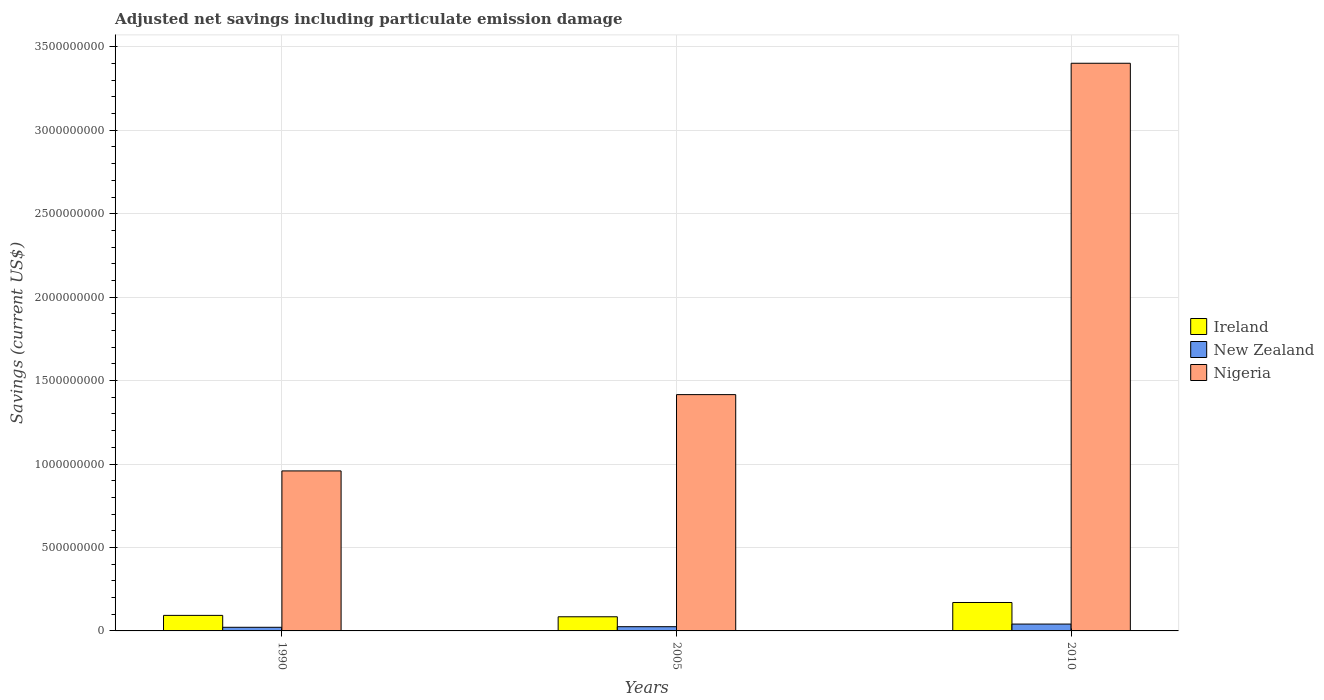How many different coloured bars are there?
Offer a terse response. 3. Are the number of bars per tick equal to the number of legend labels?
Provide a short and direct response. Yes. How many bars are there on the 2nd tick from the left?
Your response must be concise. 3. How many bars are there on the 3rd tick from the right?
Your response must be concise. 3. What is the label of the 1st group of bars from the left?
Make the answer very short. 1990. In how many cases, is the number of bars for a given year not equal to the number of legend labels?
Make the answer very short. 0. What is the net savings in Ireland in 2005?
Provide a succinct answer. 8.48e+07. Across all years, what is the maximum net savings in New Zealand?
Ensure brevity in your answer.  4.10e+07. Across all years, what is the minimum net savings in Nigeria?
Offer a very short reply. 9.59e+08. In which year was the net savings in Ireland minimum?
Keep it short and to the point. 2005. What is the total net savings in New Zealand in the graph?
Provide a succinct answer. 8.81e+07. What is the difference between the net savings in New Zealand in 2005 and that in 2010?
Provide a succinct answer. -1.57e+07. What is the difference between the net savings in Ireland in 2005 and the net savings in New Zealand in 1990?
Provide a succinct answer. 6.30e+07. What is the average net savings in New Zealand per year?
Your response must be concise. 2.94e+07. In the year 1990, what is the difference between the net savings in New Zealand and net savings in Nigeria?
Your response must be concise. -9.37e+08. What is the ratio of the net savings in Ireland in 1990 to that in 2010?
Your answer should be very brief. 0.55. Is the net savings in Ireland in 1990 less than that in 2005?
Offer a very short reply. No. Is the difference between the net savings in New Zealand in 1990 and 2010 greater than the difference between the net savings in Nigeria in 1990 and 2010?
Give a very brief answer. Yes. What is the difference between the highest and the second highest net savings in Ireland?
Make the answer very short. 7.72e+07. What is the difference between the highest and the lowest net savings in Nigeria?
Provide a succinct answer. 2.44e+09. Is the sum of the net savings in New Zealand in 2005 and 2010 greater than the maximum net savings in Nigeria across all years?
Offer a very short reply. No. What does the 1st bar from the left in 2005 represents?
Offer a terse response. Ireland. What does the 3rd bar from the right in 2005 represents?
Give a very brief answer. Ireland. Is it the case that in every year, the sum of the net savings in New Zealand and net savings in Ireland is greater than the net savings in Nigeria?
Your response must be concise. No. How many bars are there?
Your answer should be very brief. 9. Are all the bars in the graph horizontal?
Your answer should be compact. No. How many years are there in the graph?
Offer a very short reply. 3. Does the graph contain any zero values?
Your answer should be very brief. No. Does the graph contain grids?
Your answer should be compact. Yes. How many legend labels are there?
Provide a short and direct response. 3. What is the title of the graph?
Ensure brevity in your answer.  Adjusted net savings including particulate emission damage. What is the label or title of the Y-axis?
Your answer should be very brief. Savings (current US$). What is the Savings (current US$) of Ireland in 1990?
Give a very brief answer. 9.31e+07. What is the Savings (current US$) of New Zealand in 1990?
Your answer should be compact. 2.18e+07. What is the Savings (current US$) of Nigeria in 1990?
Provide a short and direct response. 9.59e+08. What is the Savings (current US$) in Ireland in 2005?
Offer a very short reply. 8.48e+07. What is the Savings (current US$) in New Zealand in 2005?
Keep it short and to the point. 2.54e+07. What is the Savings (current US$) of Nigeria in 2005?
Ensure brevity in your answer.  1.42e+09. What is the Savings (current US$) in Ireland in 2010?
Your response must be concise. 1.70e+08. What is the Savings (current US$) in New Zealand in 2010?
Your response must be concise. 4.10e+07. What is the Savings (current US$) in Nigeria in 2010?
Your response must be concise. 3.40e+09. Across all years, what is the maximum Savings (current US$) of Ireland?
Offer a very short reply. 1.70e+08. Across all years, what is the maximum Savings (current US$) in New Zealand?
Make the answer very short. 4.10e+07. Across all years, what is the maximum Savings (current US$) of Nigeria?
Your answer should be very brief. 3.40e+09. Across all years, what is the minimum Savings (current US$) of Ireland?
Ensure brevity in your answer.  8.48e+07. Across all years, what is the minimum Savings (current US$) in New Zealand?
Keep it short and to the point. 2.18e+07. Across all years, what is the minimum Savings (current US$) of Nigeria?
Provide a succinct answer. 9.59e+08. What is the total Savings (current US$) of Ireland in the graph?
Make the answer very short. 3.48e+08. What is the total Savings (current US$) of New Zealand in the graph?
Your response must be concise. 8.81e+07. What is the total Savings (current US$) of Nigeria in the graph?
Ensure brevity in your answer.  5.78e+09. What is the difference between the Savings (current US$) in Ireland in 1990 and that in 2005?
Keep it short and to the point. 8.30e+06. What is the difference between the Savings (current US$) in New Zealand in 1990 and that in 2005?
Offer a very short reply. -3.60e+06. What is the difference between the Savings (current US$) in Nigeria in 1990 and that in 2005?
Your answer should be compact. -4.57e+08. What is the difference between the Savings (current US$) in Ireland in 1990 and that in 2010?
Provide a succinct answer. -7.72e+07. What is the difference between the Savings (current US$) of New Zealand in 1990 and that in 2010?
Provide a short and direct response. -1.93e+07. What is the difference between the Savings (current US$) of Nigeria in 1990 and that in 2010?
Offer a very short reply. -2.44e+09. What is the difference between the Savings (current US$) in Ireland in 2005 and that in 2010?
Offer a terse response. -8.55e+07. What is the difference between the Savings (current US$) of New Zealand in 2005 and that in 2010?
Keep it short and to the point. -1.57e+07. What is the difference between the Savings (current US$) of Nigeria in 2005 and that in 2010?
Provide a short and direct response. -1.99e+09. What is the difference between the Savings (current US$) in Ireland in 1990 and the Savings (current US$) in New Zealand in 2005?
Offer a terse response. 6.77e+07. What is the difference between the Savings (current US$) in Ireland in 1990 and the Savings (current US$) in Nigeria in 2005?
Your answer should be compact. -1.32e+09. What is the difference between the Savings (current US$) in New Zealand in 1990 and the Savings (current US$) in Nigeria in 2005?
Offer a very short reply. -1.39e+09. What is the difference between the Savings (current US$) of Ireland in 1990 and the Savings (current US$) of New Zealand in 2010?
Give a very brief answer. 5.21e+07. What is the difference between the Savings (current US$) in Ireland in 1990 and the Savings (current US$) in Nigeria in 2010?
Provide a succinct answer. -3.31e+09. What is the difference between the Savings (current US$) in New Zealand in 1990 and the Savings (current US$) in Nigeria in 2010?
Give a very brief answer. -3.38e+09. What is the difference between the Savings (current US$) in Ireland in 2005 and the Savings (current US$) in New Zealand in 2010?
Provide a succinct answer. 4.38e+07. What is the difference between the Savings (current US$) of Ireland in 2005 and the Savings (current US$) of Nigeria in 2010?
Your answer should be very brief. -3.32e+09. What is the difference between the Savings (current US$) of New Zealand in 2005 and the Savings (current US$) of Nigeria in 2010?
Ensure brevity in your answer.  -3.38e+09. What is the average Savings (current US$) in Ireland per year?
Ensure brevity in your answer.  1.16e+08. What is the average Savings (current US$) in New Zealand per year?
Make the answer very short. 2.94e+07. What is the average Savings (current US$) of Nigeria per year?
Give a very brief answer. 1.93e+09. In the year 1990, what is the difference between the Savings (current US$) in Ireland and Savings (current US$) in New Zealand?
Offer a very short reply. 7.13e+07. In the year 1990, what is the difference between the Savings (current US$) in Ireland and Savings (current US$) in Nigeria?
Offer a terse response. -8.66e+08. In the year 1990, what is the difference between the Savings (current US$) of New Zealand and Savings (current US$) of Nigeria?
Provide a short and direct response. -9.37e+08. In the year 2005, what is the difference between the Savings (current US$) in Ireland and Savings (current US$) in New Zealand?
Offer a terse response. 5.94e+07. In the year 2005, what is the difference between the Savings (current US$) in Ireland and Savings (current US$) in Nigeria?
Offer a very short reply. -1.33e+09. In the year 2005, what is the difference between the Savings (current US$) of New Zealand and Savings (current US$) of Nigeria?
Your response must be concise. -1.39e+09. In the year 2010, what is the difference between the Savings (current US$) of Ireland and Savings (current US$) of New Zealand?
Offer a very short reply. 1.29e+08. In the year 2010, what is the difference between the Savings (current US$) of Ireland and Savings (current US$) of Nigeria?
Your answer should be compact. -3.23e+09. In the year 2010, what is the difference between the Savings (current US$) of New Zealand and Savings (current US$) of Nigeria?
Provide a short and direct response. -3.36e+09. What is the ratio of the Savings (current US$) in Ireland in 1990 to that in 2005?
Provide a succinct answer. 1.1. What is the ratio of the Savings (current US$) in New Zealand in 1990 to that in 2005?
Your response must be concise. 0.86. What is the ratio of the Savings (current US$) in Nigeria in 1990 to that in 2005?
Offer a very short reply. 0.68. What is the ratio of the Savings (current US$) of Ireland in 1990 to that in 2010?
Your answer should be very brief. 0.55. What is the ratio of the Savings (current US$) of New Zealand in 1990 to that in 2010?
Provide a short and direct response. 0.53. What is the ratio of the Savings (current US$) in Nigeria in 1990 to that in 2010?
Your answer should be very brief. 0.28. What is the ratio of the Savings (current US$) in Ireland in 2005 to that in 2010?
Provide a short and direct response. 0.5. What is the ratio of the Savings (current US$) in New Zealand in 2005 to that in 2010?
Offer a very short reply. 0.62. What is the ratio of the Savings (current US$) in Nigeria in 2005 to that in 2010?
Ensure brevity in your answer.  0.42. What is the difference between the highest and the second highest Savings (current US$) of Ireland?
Offer a very short reply. 7.72e+07. What is the difference between the highest and the second highest Savings (current US$) of New Zealand?
Ensure brevity in your answer.  1.57e+07. What is the difference between the highest and the second highest Savings (current US$) of Nigeria?
Offer a terse response. 1.99e+09. What is the difference between the highest and the lowest Savings (current US$) of Ireland?
Give a very brief answer. 8.55e+07. What is the difference between the highest and the lowest Savings (current US$) in New Zealand?
Your answer should be compact. 1.93e+07. What is the difference between the highest and the lowest Savings (current US$) of Nigeria?
Ensure brevity in your answer.  2.44e+09. 